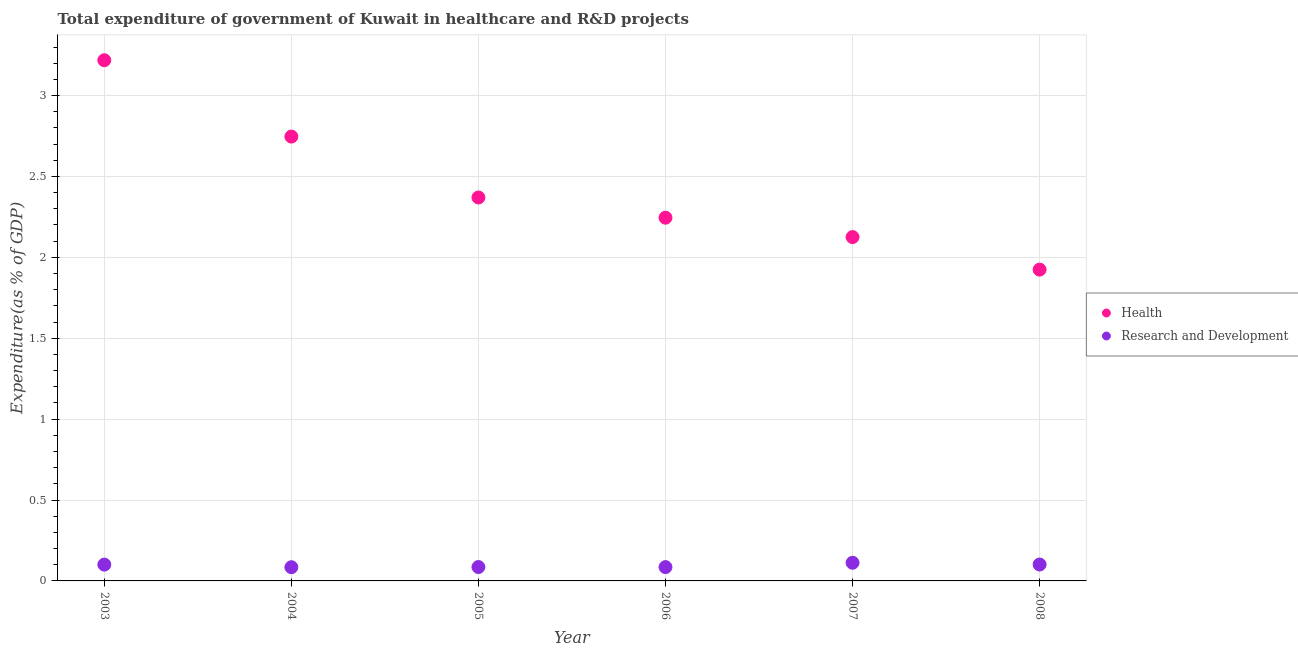Is the number of dotlines equal to the number of legend labels?
Your answer should be very brief. Yes. What is the expenditure in healthcare in 2007?
Provide a short and direct response. 2.13. Across all years, what is the maximum expenditure in healthcare?
Your answer should be compact. 3.22. Across all years, what is the minimum expenditure in r&d?
Make the answer very short. 0.08. In which year was the expenditure in healthcare minimum?
Provide a short and direct response. 2008. What is the total expenditure in r&d in the graph?
Offer a very short reply. 0.57. What is the difference between the expenditure in healthcare in 2004 and that in 2006?
Make the answer very short. 0.5. What is the difference between the expenditure in r&d in 2004 and the expenditure in healthcare in 2008?
Your answer should be very brief. -1.84. What is the average expenditure in r&d per year?
Give a very brief answer. 0.1. In the year 2007, what is the difference between the expenditure in r&d and expenditure in healthcare?
Your response must be concise. -2.01. What is the ratio of the expenditure in healthcare in 2006 to that in 2008?
Offer a terse response. 1.17. Is the expenditure in r&d in 2004 less than that in 2008?
Provide a short and direct response. Yes. What is the difference between the highest and the second highest expenditure in r&d?
Offer a very short reply. 0.01. What is the difference between the highest and the lowest expenditure in r&d?
Your answer should be compact. 0.03. Does the expenditure in healthcare monotonically increase over the years?
Your answer should be compact. No. How many years are there in the graph?
Your answer should be very brief. 6. Are the values on the major ticks of Y-axis written in scientific E-notation?
Give a very brief answer. No. Does the graph contain any zero values?
Ensure brevity in your answer.  No. Does the graph contain grids?
Your answer should be compact. Yes. Where does the legend appear in the graph?
Ensure brevity in your answer.  Center right. How many legend labels are there?
Your response must be concise. 2. How are the legend labels stacked?
Provide a succinct answer. Vertical. What is the title of the graph?
Your answer should be compact. Total expenditure of government of Kuwait in healthcare and R&D projects. What is the label or title of the X-axis?
Your answer should be compact. Year. What is the label or title of the Y-axis?
Your answer should be compact. Expenditure(as % of GDP). What is the Expenditure(as % of GDP) in Health in 2003?
Provide a succinct answer. 3.22. What is the Expenditure(as % of GDP) of Research and Development in 2003?
Provide a succinct answer. 0.1. What is the Expenditure(as % of GDP) of Health in 2004?
Your answer should be compact. 2.75. What is the Expenditure(as % of GDP) in Research and Development in 2004?
Provide a succinct answer. 0.08. What is the Expenditure(as % of GDP) of Health in 2005?
Offer a terse response. 2.37. What is the Expenditure(as % of GDP) of Research and Development in 2005?
Your response must be concise. 0.09. What is the Expenditure(as % of GDP) of Health in 2006?
Provide a short and direct response. 2.25. What is the Expenditure(as % of GDP) in Research and Development in 2006?
Offer a terse response. 0.09. What is the Expenditure(as % of GDP) in Health in 2007?
Your answer should be compact. 2.13. What is the Expenditure(as % of GDP) of Research and Development in 2007?
Offer a terse response. 0.11. What is the Expenditure(as % of GDP) of Health in 2008?
Make the answer very short. 1.92. What is the Expenditure(as % of GDP) in Research and Development in 2008?
Offer a very short reply. 0.1. Across all years, what is the maximum Expenditure(as % of GDP) of Health?
Give a very brief answer. 3.22. Across all years, what is the maximum Expenditure(as % of GDP) of Research and Development?
Offer a very short reply. 0.11. Across all years, what is the minimum Expenditure(as % of GDP) in Health?
Give a very brief answer. 1.92. Across all years, what is the minimum Expenditure(as % of GDP) in Research and Development?
Provide a succinct answer. 0.08. What is the total Expenditure(as % of GDP) in Health in the graph?
Give a very brief answer. 14.63. What is the total Expenditure(as % of GDP) in Research and Development in the graph?
Provide a short and direct response. 0.57. What is the difference between the Expenditure(as % of GDP) in Health in 2003 and that in 2004?
Offer a terse response. 0.47. What is the difference between the Expenditure(as % of GDP) of Research and Development in 2003 and that in 2004?
Your answer should be very brief. 0.02. What is the difference between the Expenditure(as % of GDP) of Health in 2003 and that in 2005?
Give a very brief answer. 0.85. What is the difference between the Expenditure(as % of GDP) of Research and Development in 2003 and that in 2005?
Offer a terse response. 0.01. What is the difference between the Expenditure(as % of GDP) of Health in 2003 and that in 2006?
Keep it short and to the point. 0.97. What is the difference between the Expenditure(as % of GDP) in Research and Development in 2003 and that in 2006?
Your answer should be very brief. 0.02. What is the difference between the Expenditure(as % of GDP) of Health in 2003 and that in 2007?
Your answer should be compact. 1.09. What is the difference between the Expenditure(as % of GDP) of Research and Development in 2003 and that in 2007?
Your answer should be compact. -0.01. What is the difference between the Expenditure(as % of GDP) of Health in 2003 and that in 2008?
Your answer should be compact. 1.29. What is the difference between the Expenditure(as % of GDP) of Research and Development in 2003 and that in 2008?
Ensure brevity in your answer.  -0. What is the difference between the Expenditure(as % of GDP) of Health in 2004 and that in 2005?
Give a very brief answer. 0.38. What is the difference between the Expenditure(as % of GDP) of Research and Development in 2004 and that in 2005?
Keep it short and to the point. -0. What is the difference between the Expenditure(as % of GDP) in Health in 2004 and that in 2006?
Keep it short and to the point. 0.5. What is the difference between the Expenditure(as % of GDP) in Research and Development in 2004 and that in 2006?
Ensure brevity in your answer.  -0. What is the difference between the Expenditure(as % of GDP) of Health in 2004 and that in 2007?
Offer a very short reply. 0.62. What is the difference between the Expenditure(as % of GDP) in Research and Development in 2004 and that in 2007?
Keep it short and to the point. -0.03. What is the difference between the Expenditure(as % of GDP) in Health in 2004 and that in 2008?
Provide a succinct answer. 0.82. What is the difference between the Expenditure(as % of GDP) in Research and Development in 2004 and that in 2008?
Your response must be concise. -0.02. What is the difference between the Expenditure(as % of GDP) in Health in 2005 and that in 2006?
Give a very brief answer. 0.12. What is the difference between the Expenditure(as % of GDP) of Research and Development in 2005 and that in 2006?
Give a very brief answer. 0. What is the difference between the Expenditure(as % of GDP) in Health in 2005 and that in 2007?
Give a very brief answer. 0.24. What is the difference between the Expenditure(as % of GDP) in Research and Development in 2005 and that in 2007?
Keep it short and to the point. -0.03. What is the difference between the Expenditure(as % of GDP) of Health in 2005 and that in 2008?
Your answer should be compact. 0.45. What is the difference between the Expenditure(as % of GDP) in Research and Development in 2005 and that in 2008?
Provide a short and direct response. -0.02. What is the difference between the Expenditure(as % of GDP) in Health in 2006 and that in 2007?
Offer a terse response. 0.12. What is the difference between the Expenditure(as % of GDP) of Research and Development in 2006 and that in 2007?
Make the answer very short. -0.03. What is the difference between the Expenditure(as % of GDP) in Health in 2006 and that in 2008?
Offer a terse response. 0.32. What is the difference between the Expenditure(as % of GDP) of Research and Development in 2006 and that in 2008?
Offer a terse response. -0.02. What is the difference between the Expenditure(as % of GDP) in Health in 2007 and that in 2008?
Ensure brevity in your answer.  0.2. What is the difference between the Expenditure(as % of GDP) in Research and Development in 2007 and that in 2008?
Provide a succinct answer. 0.01. What is the difference between the Expenditure(as % of GDP) of Health in 2003 and the Expenditure(as % of GDP) of Research and Development in 2004?
Offer a very short reply. 3.13. What is the difference between the Expenditure(as % of GDP) of Health in 2003 and the Expenditure(as % of GDP) of Research and Development in 2005?
Offer a terse response. 3.13. What is the difference between the Expenditure(as % of GDP) of Health in 2003 and the Expenditure(as % of GDP) of Research and Development in 2006?
Give a very brief answer. 3.13. What is the difference between the Expenditure(as % of GDP) of Health in 2003 and the Expenditure(as % of GDP) of Research and Development in 2007?
Provide a short and direct response. 3.11. What is the difference between the Expenditure(as % of GDP) in Health in 2003 and the Expenditure(as % of GDP) in Research and Development in 2008?
Provide a short and direct response. 3.12. What is the difference between the Expenditure(as % of GDP) of Health in 2004 and the Expenditure(as % of GDP) of Research and Development in 2005?
Provide a short and direct response. 2.66. What is the difference between the Expenditure(as % of GDP) of Health in 2004 and the Expenditure(as % of GDP) of Research and Development in 2006?
Your answer should be compact. 2.66. What is the difference between the Expenditure(as % of GDP) in Health in 2004 and the Expenditure(as % of GDP) in Research and Development in 2007?
Offer a terse response. 2.63. What is the difference between the Expenditure(as % of GDP) in Health in 2004 and the Expenditure(as % of GDP) in Research and Development in 2008?
Give a very brief answer. 2.64. What is the difference between the Expenditure(as % of GDP) of Health in 2005 and the Expenditure(as % of GDP) of Research and Development in 2006?
Offer a terse response. 2.28. What is the difference between the Expenditure(as % of GDP) in Health in 2005 and the Expenditure(as % of GDP) in Research and Development in 2007?
Provide a succinct answer. 2.26. What is the difference between the Expenditure(as % of GDP) of Health in 2005 and the Expenditure(as % of GDP) of Research and Development in 2008?
Provide a short and direct response. 2.27. What is the difference between the Expenditure(as % of GDP) in Health in 2006 and the Expenditure(as % of GDP) in Research and Development in 2007?
Offer a terse response. 2.13. What is the difference between the Expenditure(as % of GDP) in Health in 2006 and the Expenditure(as % of GDP) in Research and Development in 2008?
Your answer should be compact. 2.14. What is the difference between the Expenditure(as % of GDP) in Health in 2007 and the Expenditure(as % of GDP) in Research and Development in 2008?
Ensure brevity in your answer.  2.02. What is the average Expenditure(as % of GDP) of Health per year?
Give a very brief answer. 2.44. What is the average Expenditure(as % of GDP) in Research and Development per year?
Offer a terse response. 0.1. In the year 2003, what is the difference between the Expenditure(as % of GDP) of Health and Expenditure(as % of GDP) of Research and Development?
Give a very brief answer. 3.12. In the year 2004, what is the difference between the Expenditure(as % of GDP) in Health and Expenditure(as % of GDP) in Research and Development?
Keep it short and to the point. 2.66. In the year 2005, what is the difference between the Expenditure(as % of GDP) of Health and Expenditure(as % of GDP) of Research and Development?
Your answer should be very brief. 2.28. In the year 2006, what is the difference between the Expenditure(as % of GDP) in Health and Expenditure(as % of GDP) in Research and Development?
Ensure brevity in your answer.  2.16. In the year 2007, what is the difference between the Expenditure(as % of GDP) in Health and Expenditure(as % of GDP) in Research and Development?
Make the answer very short. 2.01. In the year 2008, what is the difference between the Expenditure(as % of GDP) of Health and Expenditure(as % of GDP) of Research and Development?
Keep it short and to the point. 1.82. What is the ratio of the Expenditure(as % of GDP) of Health in 2003 to that in 2004?
Your answer should be compact. 1.17. What is the ratio of the Expenditure(as % of GDP) of Research and Development in 2003 to that in 2004?
Provide a succinct answer. 1.19. What is the ratio of the Expenditure(as % of GDP) in Health in 2003 to that in 2005?
Provide a short and direct response. 1.36. What is the ratio of the Expenditure(as % of GDP) of Research and Development in 2003 to that in 2005?
Your answer should be compact. 1.17. What is the ratio of the Expenditure(as % of GDP) in Health in 2003 to that in 2006?
Your response must be concise. 1.43. What is the ratio of the Expenditure(as % of GDP) of Research and Development in 2003 to that in 2006?
Give a very brief answer. 1.18. What is the ratio of the Expenditure(as % of GDP) in Health in 2003 to that in 2007?
Make the answer very short. 1.51. What is the ratio of the Expenditure(as % of GDP) in Research and Development in 2003 to that in 2007?
Keep it short and to the point. 0.9. What is the ratio of the Expenditure(as % of GDP) of Health in 2003 to that in 2008?
Your response must be concise. 1.67. What is the ratio of the Expenditure(as % of GDP) of Health in 2004 to that in 2005?
Your response must be concise. 1.16. What is the ratio of the Expenditure(as % of GDP) in Research and Development in 2004 to that in 2005?
Your response must be concise. 0.99. What is the ratio of the Expenditure(as % of GDP) of Health in 2004 to that in 2006?
Make the answer very short. 1.22. What is the ratio of the Expenditure(as % of GDP) of Health in 2004 to that in 2007?
Give a very brief answer. 1.29. What is the ratio of the Expenditure(as % of GDP) in Research and Development in 2004 to that in 2007?
Your answer should be very brief. 0.76. What is the ratio of the Expenditure(as % of GDP) of Health in 2004 to that in 2008?
Provide a short and direct response. 1.43. What is the ratio of the Expenditure(as % of GDP) in Research and Development in 2004 to that in 2008?
Offer a very short reply. 0.84. What is the ratio of the Expenditure(as % of GDP) of Health in 2005 to that in 2006?
Ensure brevity in your answer.  1.06. What is the ratio of the Expenditure(as % of GDP) of Health in 2005 to that in 2007?
Your answer should be compact. 1.12. What is the ratio of the Expenditure(as % of GDP) of Research and Development in 2005 to that in 2007?
Offer a very short reply. 0.77. What is the ratio of the Expenditure(as % of GDP) in Health in 2005 to that in 2008?
Offer a very short reply. 1.23. What is the ratio of the Expenditure(as % of GDP) in Research and Development in 2005 to that in 2008?
Make the answer very short. 0.85. What is the ratio of the Expenditure(as % of GDP) in Health in 2006 to that in 2007?
Your response must be concise. 1.06. What is the ratio of the Expenditure(as % of GDP) in Research and Development in 2006 to that in 2007?
Your answer should be compact. 0.76. What is the ratio of the Expenditure(as % of GDP) in Health in 2006 to that in 2008?
Offer a very short reply. 1.17. What is the ratio of the Expenditure(as % of GDP) of Research and Development in 2006 to that in 2008?
Provide a short and direct response. 0.84. What is the ratio of the Expenditure(as % of GDP) in Health in 2007 to that in 2008?
Give a very brief answer. 1.1. What is the ratio of the Expenditure(as % of GDP) of Research and Development in 2007 to that in 2008?
Ensure brevity in your answer.  1.11. What is the difference between the highest and the second highest Expenditure(as % of GDP) in Health?
Your answer should be very brief. 0.47. What is the difference between the highest and the second highest Expenditure(as % of GDP) in Research and Development?
Make the answer very short. 0.01. What is the difference between the highest and the lowest Expenditure(as % of GDP) of Health?
Your answer should be compact. 1.29. What is the difference between the highest and the lowest Expenditure(as % of GDP) in Research and Development?
Your response must be concise. 0.03. 